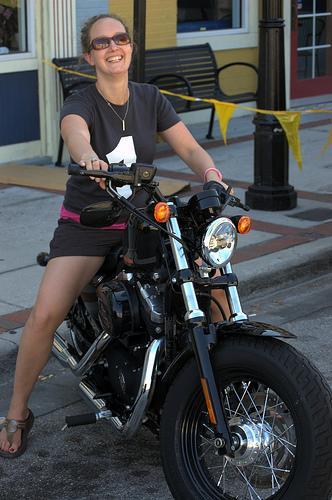Provide a short summary of the woman's overall appearance in the image. She is a stylish woman in casual clothing, with a bright smile, sunglasses, and several accessories, seated on a motorcycle. State the primary colors within the image and what they are associated with. Black for the motorcycle and bench, yellow for flags, red for door trim, and pink for the woman's shorts trim and watch. Provide a concise description of the woman's attire in the image. The woman is wearing a black top, black shorts with a pink band, brown sandals, sunglasses, and a gold necklace. Detail any accessories the woman in the image is wearing. The woman dons a pair of dark brown sunglasses, a gold necklace, and a pink watch on her arm. Compose a brief description of the woman and what she's doing in the image. A woman wearing a black top, shorts, sunglasses, and a necklace is sitting on a black motorcycle with a big smile on her face. Describe the main mode of transportation shown in the image. The main mode of transportation is a black motorcycle with orange turn signals, a headlamp, and front and back wheels. Characterize the image's atmosphere based on the objects and colors present. The image has a cheerful and colorful vibe, with the woman's smile, yellow flags, red-trimmed door, and various shades of clothing. Enumerate three prominent elements that stand out in the image. The smiling woman wearing sunglasses, the black motorcycle, and the yellow flags in the background. Explain the primary setting of the image, focusing on the background elements. The image is set on a sidewalk with a black wooden bench, yellow flags, a black light pole, a red-trimmed door, and grey pavement. Describe the footwear worn by the woman in the image. The woman is wearing brown flip-flop sandals with red painted toenails. 